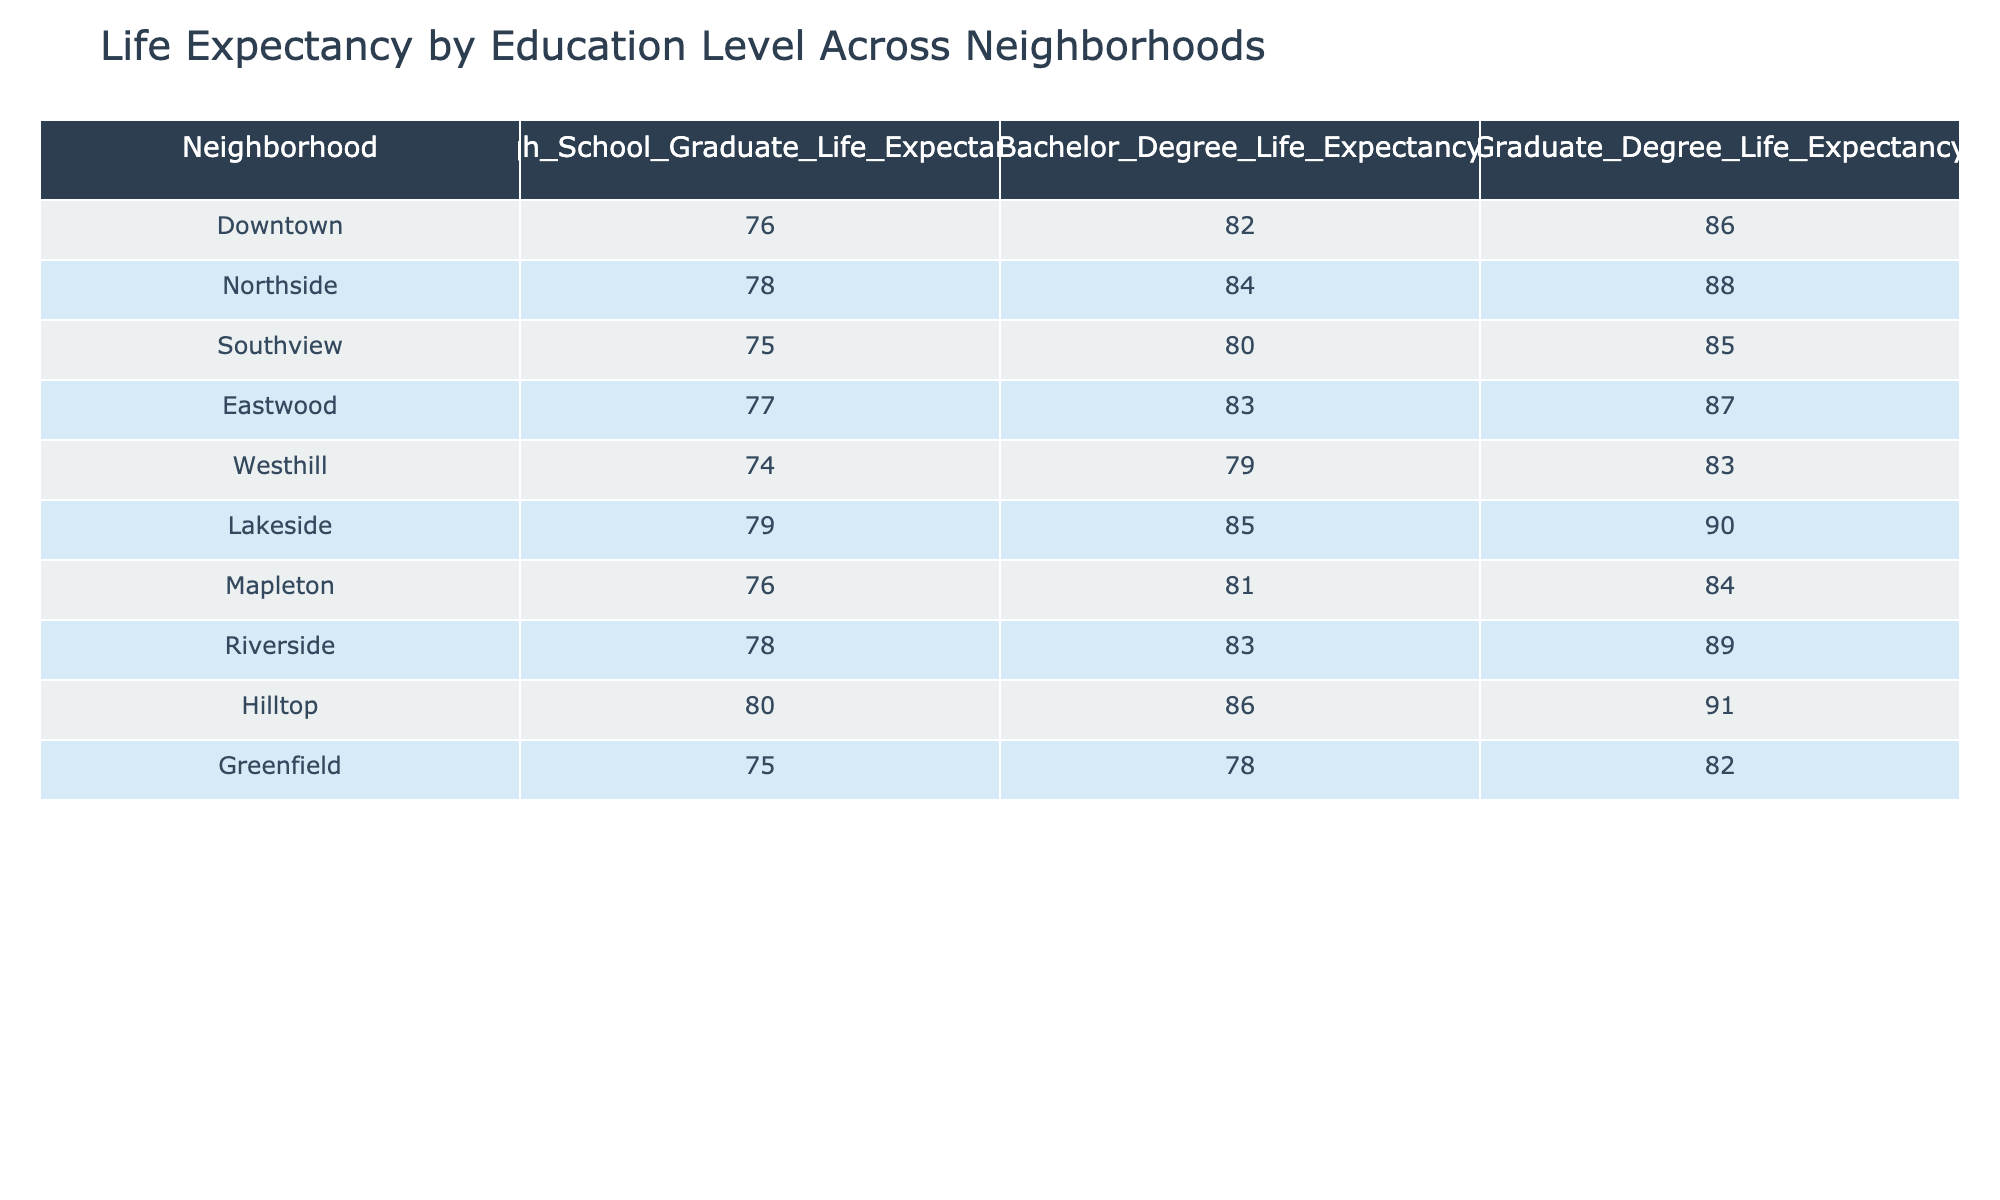What is the life expectancy for high school graduates in the Downtown neighborhood? The table shows that the life expectancy for high school graduates in the Downtown neighborhood is 76.
Answer: 76 Which neighborhood has the highest life expectancy for those with a graduate degree? According to the table, Hilltop has the highest life expectancy for those with a graduate degree at 91.
Answer: 91 What is the difference in life expectancy between high school graduates and bachelor degree holders in the Northside neighborhood? For Northside, the life expectancy for high school graduates is 78 and for bachelor degree holders is 84. The difference is 84 - 78 = 6.
Answer: 6 Is the life expectancy for graduate degree holders in Southview higher than in Westhill? The life expectancy for graduate degree holders in Southview is 85, while in Westhill it is 83. Since 85 > 83, the statement is true.
Answer: Yes What is the average life expectancy for all neighborhoods for high school graduates? The high school graduate life expectancies from all neighborhoods are: 76, 78, 75, 77, 74, 79, 76, 78, 80, 75. The sum is 76 + 78 + 75 + 77 + 74 + 79 + 76 + 78 + 80 + 75 =  760. Since there are 10 neighborhoods, the average is 760 / 10 = 76.
Answer: 76 Which neighborhood has the lowest life expectancy for all education levels combined? The table shows life expectancies across three education levels in each neighborhood. By examining the lowest values: Downtown (76, 82, 86), Northside (78, 84, 88), Southview (75, 80, 85), Eastwood (77, 83, 87), Westhill (74, 79, 83), Lakeside (79, 85, 90), Mapleton (76, 81, 84), Riverside (78, 83, 89), Hilltop (80, 86, 91), and Greenfield (75, 78, 82), the lowest value is 74 in Westhill.
Answer: Westhill How much higher is the life expectancy for bachelor degree holders in Lakeside compared to those in Mapleton? Lakeside's life expectancy for bachelor degree holders is 85 and Mapleton's is 81. The difference is 85 - 81 = 4.
Answer: 4 What percentage of neighborhoods have a higher life expectancy for graduate degree holders compared to high school graduates? The neighborhoods with higher life expectancy for graduate degree holders compared to high school graduates are: Downtown (86 > 76), Northside (88 > 78), Southview (85 > 75), Eastwood (87 > 77), Lakeside (90 > 79), Riverside (89 > 78), Hilltop (91 > 80). That's a total of 7 neighborhoods out of 10. Therefore, the percentage is (7/10) * 100 = 70%.
Answer: 70% 